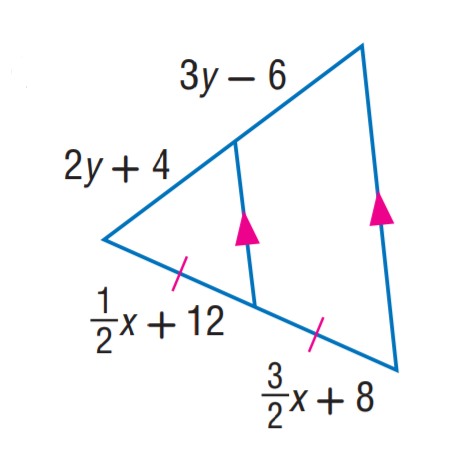Answer the mathemtical geometry problem and directly provide the correct option letter.
Question: Find x.
Choices: A: 4 B: 6 C: 8 D: 10 A 